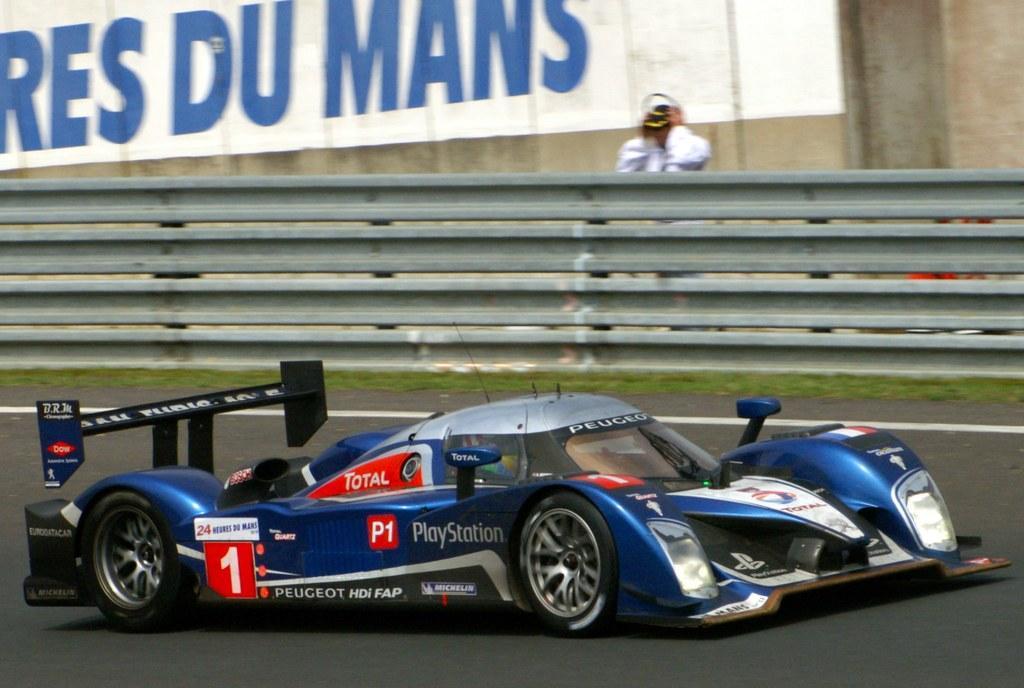Can you describe this image briefly? At the bottom of this image, there is a vehicle on a road on which there is a white color line. In the background, there is grass, a fence, a person and a painting on a wall. 